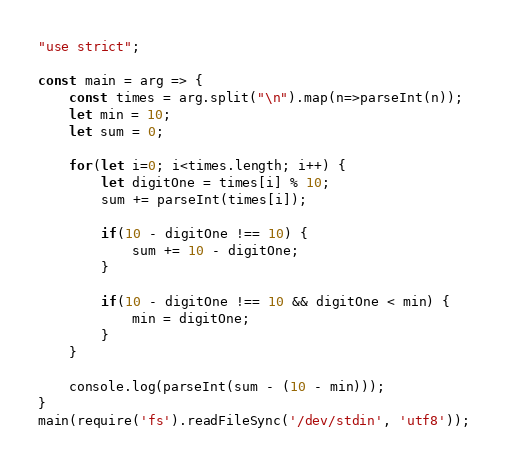Convert code to text. <code><loc_0><loc_0><loc_500><loc_500><_JavaScript_>"use strict";
    
const main = arg => {
    const times = arg.split("\n").map(n=>parseInt(n));
    let min = 10;
    let sum = 0;
    
    for(let i=0; i<times.length; i++) {
        let digitOne = times[i] % 10;
        sum += parseInt(times[i]);
        
        if(10 - digitOne !== 10) {
            sum += 10 - digitOne;
        }
        
        if(10 - digitOne !== 10 && digitOne < min) {
            min = digitOne;
        }
    }

    console.log(parseInt(sum - (10 - min)));
}
main(require('fs').readFileSync('/dev/stdin', 'utf8'));
</code> 